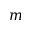Convert formula to latex. <formula><loc_0><loc_0><loc_500><loc_500>m</formula> 